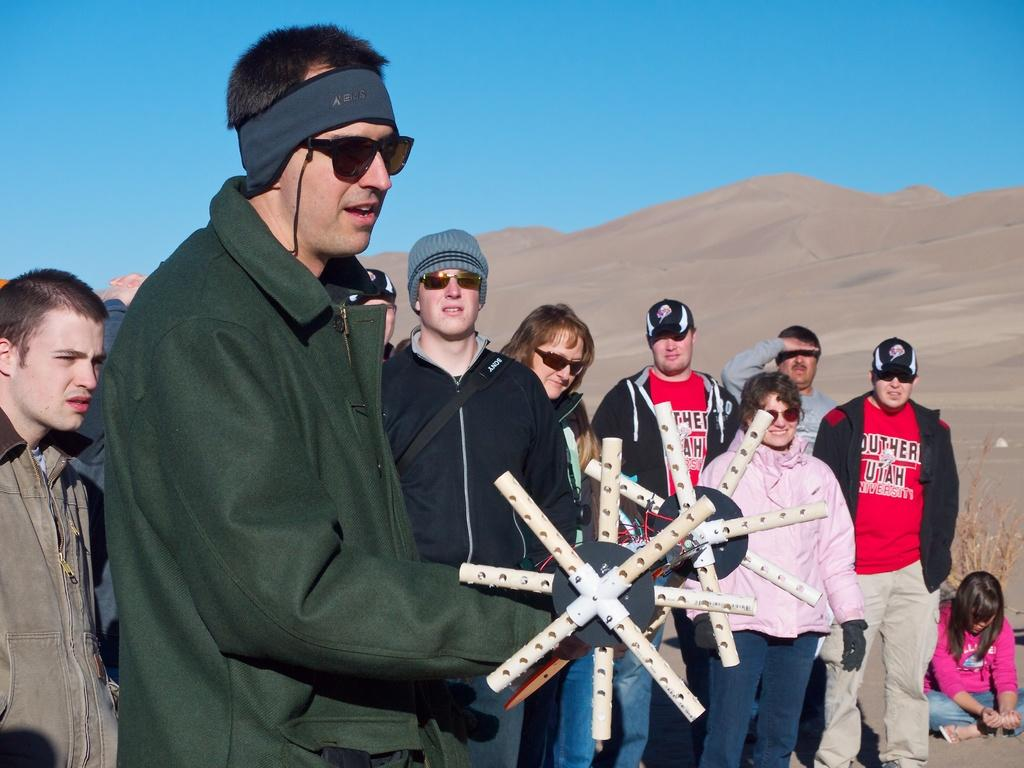What are the people in the image doing? There is a group of people standing on a path in the image. Can you describe the woman's position in the image? A woman is sitting in the image. What is the person holding in the image? A person is holding an object in the image. What can be seen in the background of the image? There is a plant, a hill, and the sky visible in the background of the image. What type of brush is being used to paint the hill in the image? There is no brush or painting activity present in the image; it features a group of people, a sitting woman, and a person holding an object. 